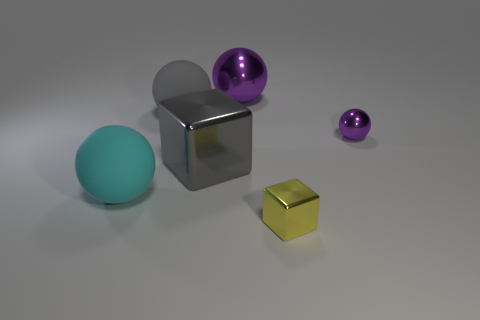Subtract all brown blocks. How many purple spheres are left? 2 Subtract all cyan matte spheres. How many spheres are left? 3 Subtract all cyan balls. How many balls are left? 3 Add 2 metal cubes. How many objects exist? 8 Subtract all balls. How many objects are left? 2 Subtract all blue balls. Subtract all gray blocks. How many balls are left? 4 Subtract 1 cyan spheres. How many objects are left? 5 Subtract all gray rubber spheres. Subtract all large things. How many objects are left? 1 Add 6 purple balls. How many purple balls are left? 8 Add 3 purple spheres. How many purple spheres exist? 5 